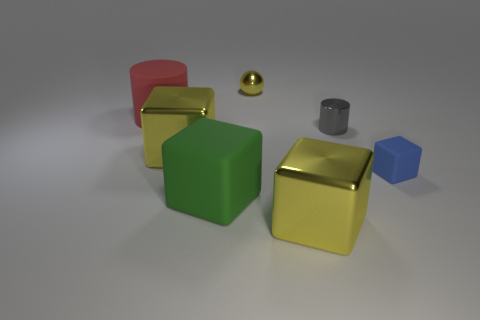Do the large metallic block that is left of the tiny metal sphere and the small ball have the same color?
Offer a very short reply. Yes. How many shiny blocks have the same color as the tiny ball?
Keep it short and to the point. 2. Do the blue thing and the gray cylinder have the same size?
Give a very brief answer. Yes. Are there an equal number of objects right of the small blue rubber cube and metallic objects that are to the right of the yellow ball?
Offer a terse response. No. Is there a large cylinder?
Offer a very short reply. Yes. What is the size of the other matte thing that is the same shape as the blue thing?
Your response must be concise. Large. How big is the cylinder left of the gray cylinder?
Your answer should be very brief. Large. Are there more large metallic things left of the green matte cube than purple shiny cylinders?
Your answer should be compact. Yes. There is a small gray metal object; what shape is it?
Your answer should be very brief. Cylinder. There is a tiny metal thing that is in front of the red rubber cylinder; is its color the same as the tiny object that is behind the big red object?
Keep it short and to the point. No. 